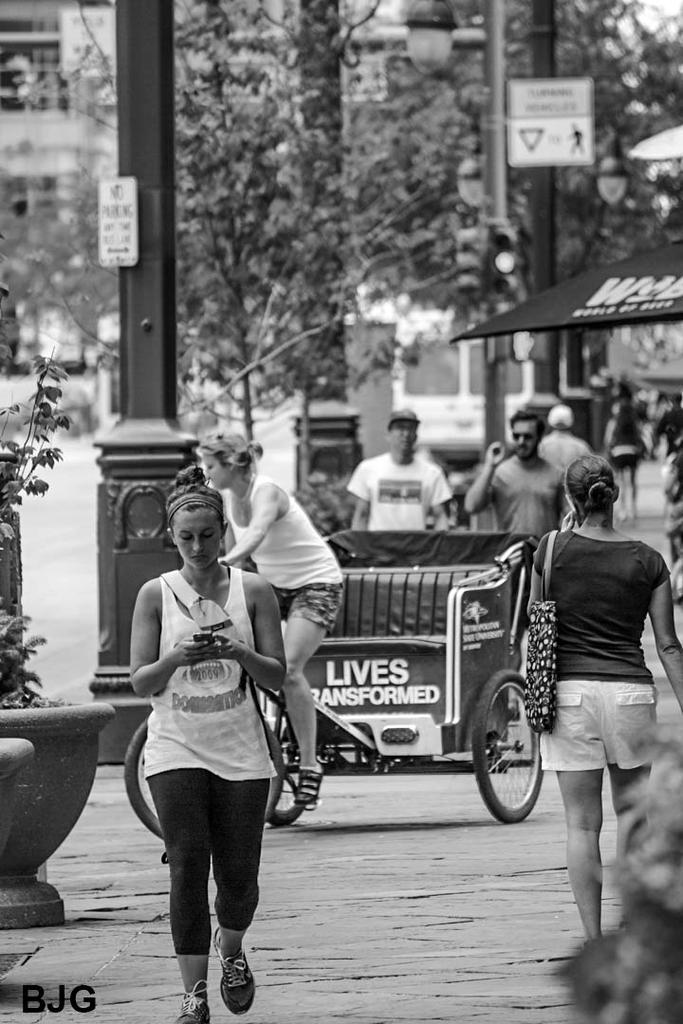Could you give a brief overview of what you see in this image? This is a black and white picture. This picture is clicked outside the city. At the bottom, we see the road. In front of the picture, we see a woman is walking and she is holding a mobile phone in her hands. Behind her, we see a woman is riding a rickshaw. On the right side, we see a woman is standing and she is wearing a handbag. We see a board in black color with some text written. On the left side, we see a plant pot. Behind that, we see a pole and a board in white color with some text written. In the background, we see three men are standing and behind them, we see a pole and a board in white color with some text written. There are trees and the buildings in the background. 